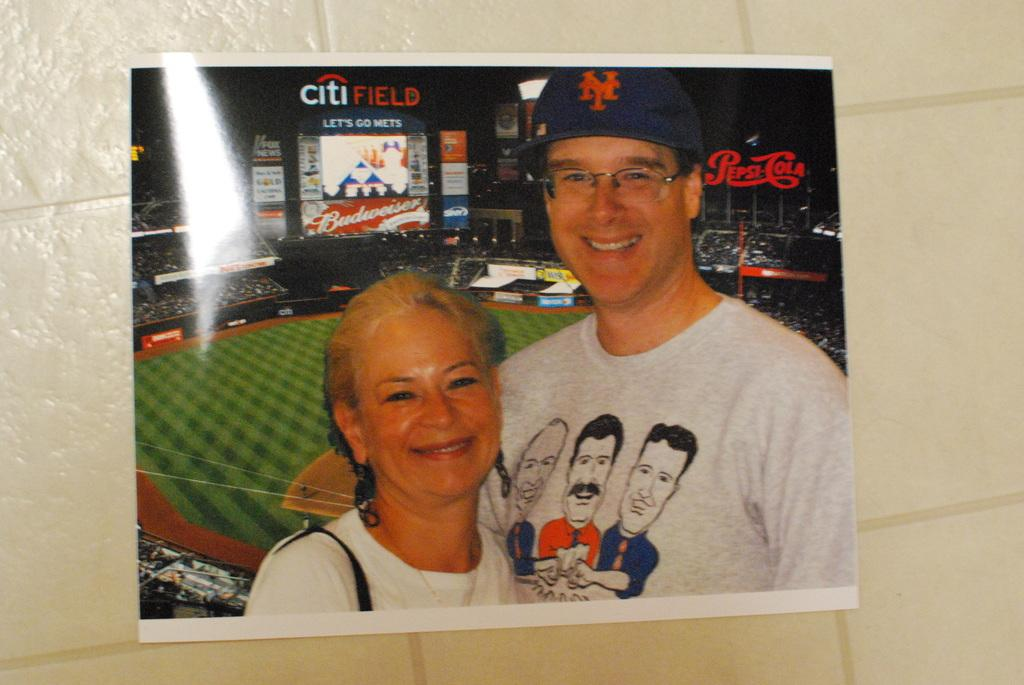What is depicted on the poster in the image? The poster features a man and a woman. Where is the poster located in the image? The location of the poster is not specified, but it is present in the image. What can be seen in the background of the image? There is a playground in the background of the image. What type of hospital equipment can be seen in the image? There is no hospital equipment present in the image; it features a poster with a man and a woman, and a playground in the background. Can you tell me how many beetles are crawling on the poster? There are no beetles present on the poster or in the image. 